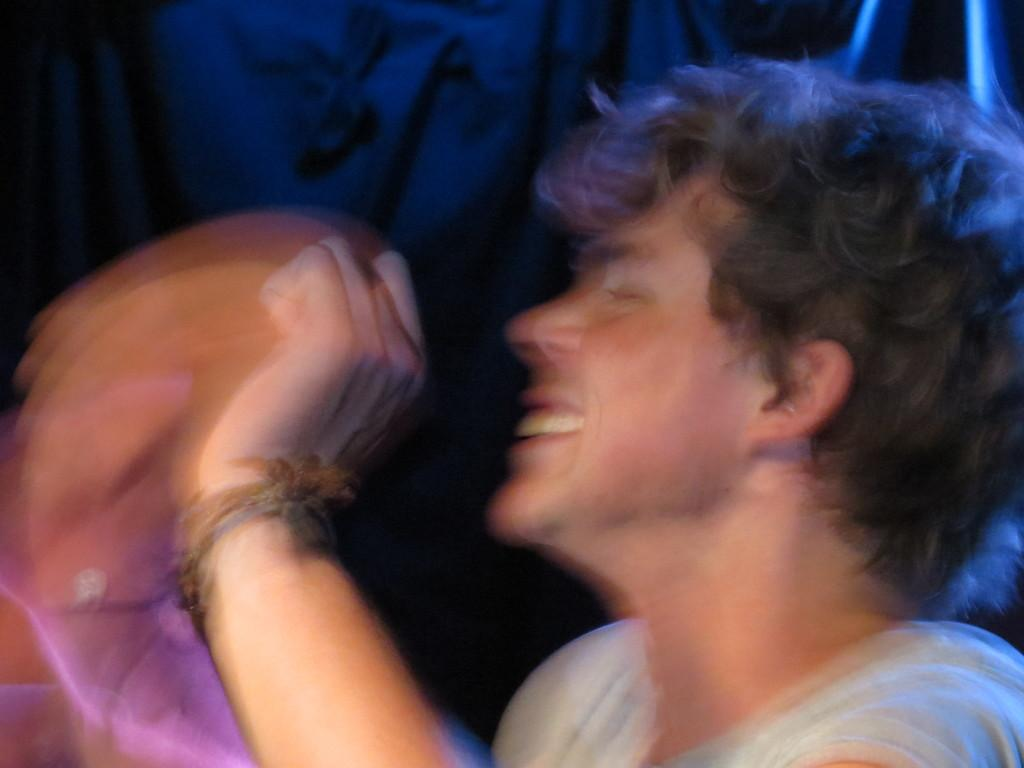What is the main subject of the picture? The main subject of the picture is a blurry image of a person. Can you describe the background of the image? The background of the image is dark. What type of yoke is being used by the person in the image? There is no yoke present in the image; it features a blurry image of a person with a dark background. 